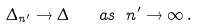<formula> <loc_0><loc_0><loc_500><loc_500>\Delta _ { n ^ { \prime } } \rightarrow \Delta \quad a s \ n ^ { \prime } \to \infty \, .</formula> 